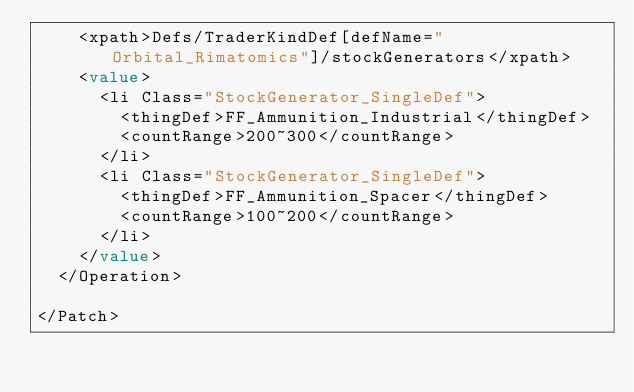<code> <loc_0><loc_0><loc_500><loc_500><_XML_>    <xpath>Defs/TraderKindDef[defName="Orbital_Rimatomics"]/stockGenerators</xpath>
    <value>
      <li Class="StockGenerator_SingleDef">
        <thingDef>FF_Ammunition_Industrial</thingDef>
        <countRange>200~300</countRange>
      </li>
      <li Class="StockGenerator_SingleDef">
        <thingDef>FF_Ammunition_Spacer</thingDef>
        <countRange>100~200</countRange>
      </li>
    </value>
  </Operation>

</Patch></code> 